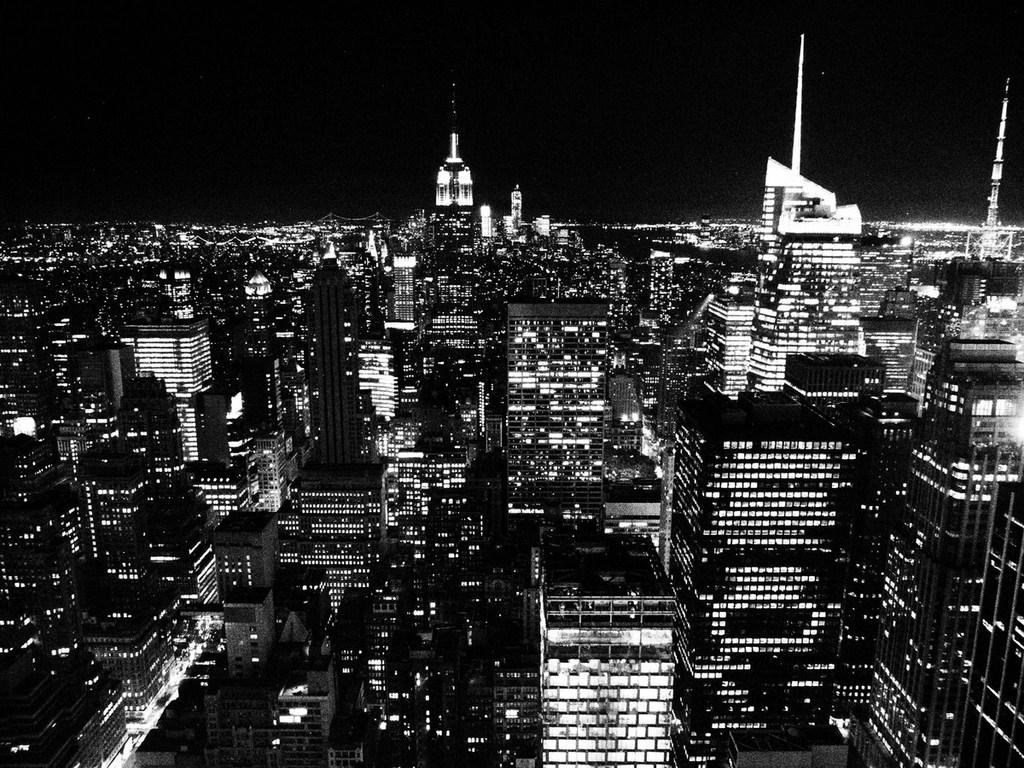What is the color scheme of the image? The image is black and white. What can be seen in the middle of the image? There are multiple buildings in the middle of the image. What is visible at the top of the image? The sky is visible at the top of the image. What feature can be observed in the buildings? There are lights in the buildings. Can you see a plate on the roof of one of the buildings in the image? There is no plate visible on the roof of any building in the image. Are there any toys hanging from the lights in the buildings? There are no toys present in the image; only the buildings and lights are visible. 